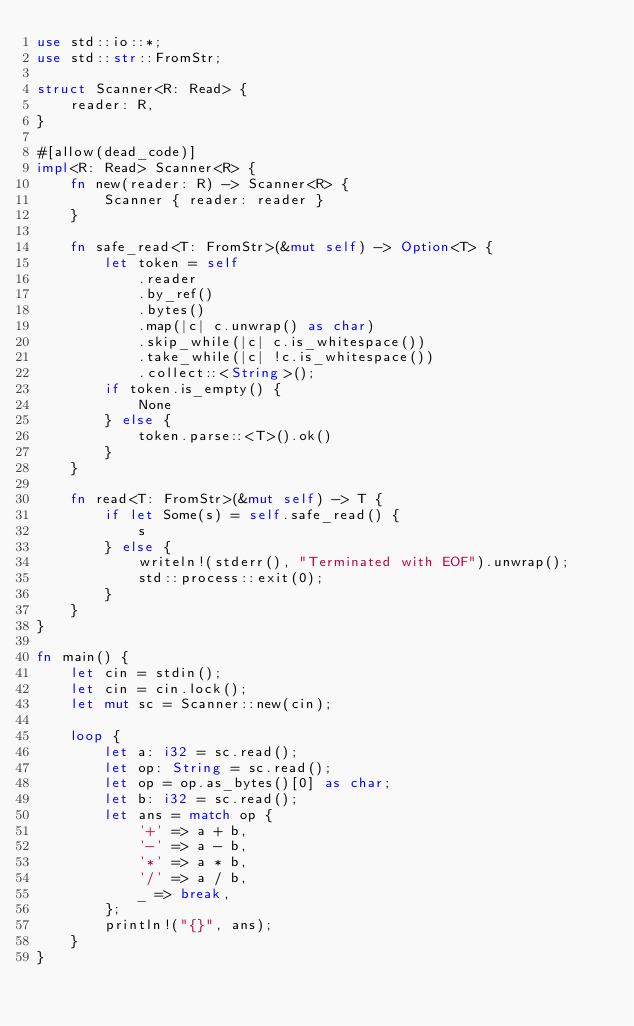Convert code to text. <code><loc_0><loc_0><loc_500><loc_500><_Rust_>use std::io::*;
use std::str::FromStr;

struct Scanner<R: Read> {
    reader: R,
}

#[allow(dead_code)]
impl<R: Read> Scanner<R> {
    fn new(reader: R) -> Scanner<R> {
        Scanner { reader: reader }
    }

    fn safe_read<T: FromStr>(&mut self) -> Option<T> {
        let token = self
            .reader
            .by_ref()
            .bytes()
            .map(|c| c.unwrap() as char)
            .skip_while(|c| c.is_whitespace())
            .take_while(|c| !c.is_whitespace())
            .collect::<String>();
        if token.is_empty() {
            None
        } else {
            token.parse::<T>().ok()
        }
    }

    fn read<T: FromStr>(&mut self) -> T {
        if let Some(s) = self.safe_read() {
            s
        } else {
            writeln!(stderr(), "Terminated with EOF").unwrap();
            std::process::exit(0);
        }
    }
}

fn main() {
    let cin = stdin();
    let cin = cin.lock();
    let mut sc = Scanner::new(cin);

    loop {
        let a: i32 = sc.read();
        let op: String = sc.read();
        let op = op.as_bytes()[0] as char;
        let b: i32 = sc.read();
        let ans = match op {
            '+' => a + b,
            '-' => a - b,
            '*' => a * b,
            '/' => a / b,
            _ => break,
        };
        println!("{}", ans);
    }
}
</code> 